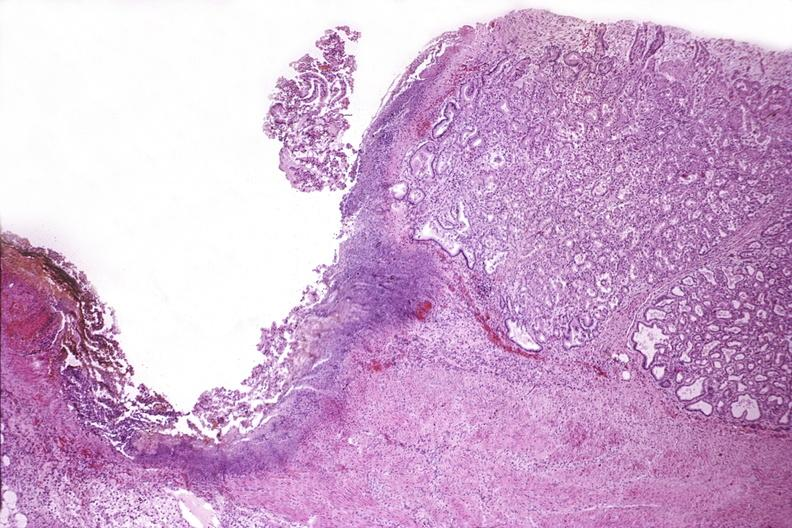where is this from?
Answer the question using a single word or phrase. Gastrointestinal system 